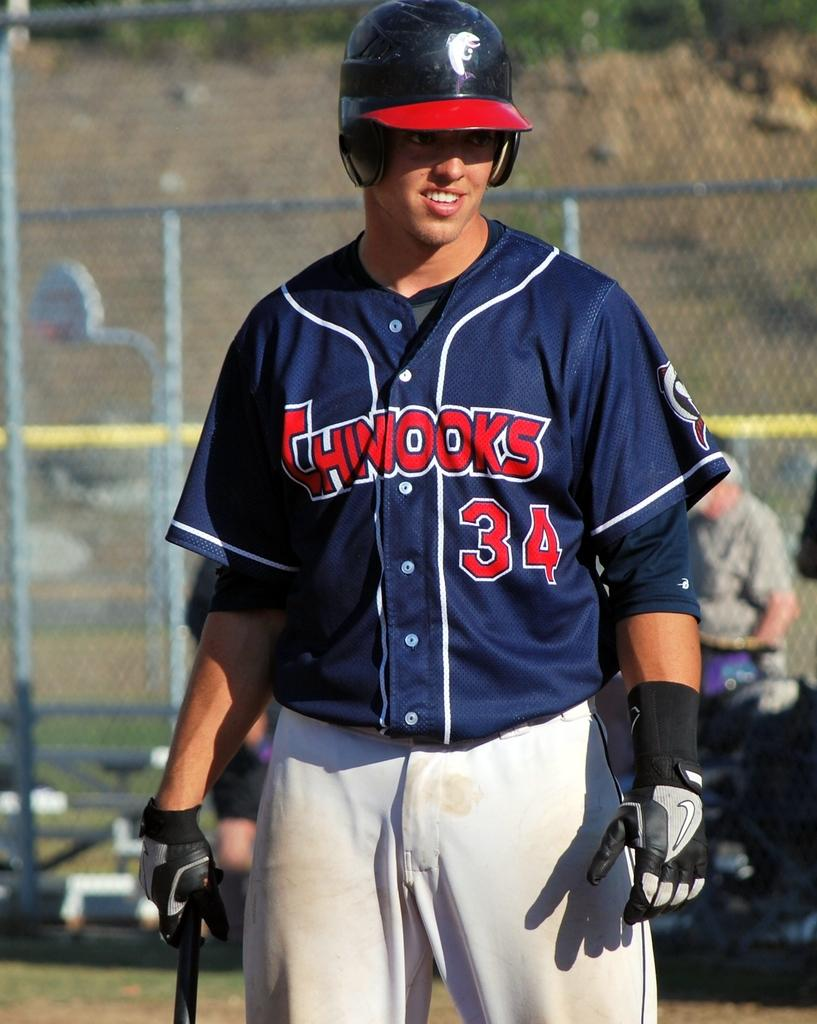<image>
Share a concise interpretation of the image provided. a baseball player that is wearing the number 34 